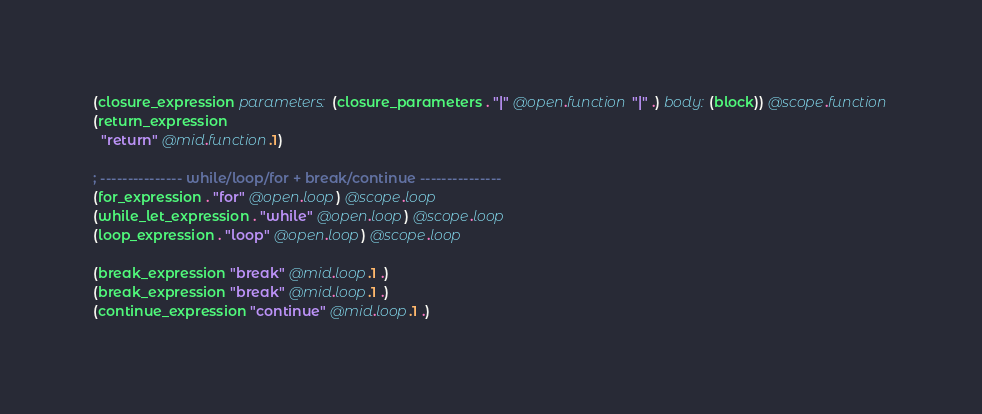<code> <loc_0><loc_0><loc_500><loc_500><_Scheme_>(closure_expression parameters: (closure_parameters . "|" @open.function "|" .) body: (block)) @scope.function
(return_expression
  "return" @mid.function.1)

; --------------- while/loop/for + break/continue ---------------
(for_expression . "for" @open.loop) @scope.loop
(while_let_expression . "while" @open.loop) @scope.loop
(loop_expression . "loop" @open.loop) @scope.loop

(break_expression "break" @mid.loop.1 .)
(break_expression "break" @mid.loop.1 .)
(continue_expression "continue" @mid.loop.1 .)
</code> 